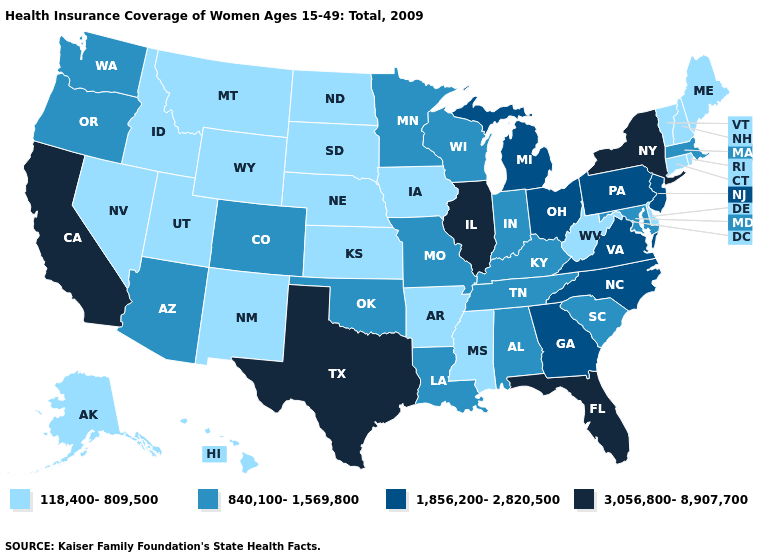Which states hav the highest value in the MidWest?
Short answer required. Illinois. Name the states that have a value in the range 118,400-809,500?
Write a very short answer. Alaska, Arkansas, Connecticut, Delaware, Hawaii, Idaho, Iowa, Kansas, Maine, Mississippi, Montana, Nebraska, Nevada, New Hampshire, New Mexico, North Dakota, Rhode Island, South Dakota, Utah, Vermont, West Virginia, Wyoming. Name the states that have a value in the range 3,056,800-8,907,700?
Quick response, please. California, Florida, Illinois, New York, Texas. What is the lowest value in the USA?
Write a very short answer. 118,400-809,500. Name the states that have a value in the range 118,400-809,500?
Concise answer only. Alaska, Arkansas, Connecticut, Delaware, Hawaii, Idaho, Iowa, Kansas, Maine, Mississippi, Montana, Nebraska, Nevada, New Hampshire, New Mexico, North Dakota, Rhode Island, South Dakota, Utah, Vermont, West Virginia, Wyoming. Name the states that have a value in the range 840,100-1,569,800?
Keep it brief. Alabama, Arizona, Colorado, Indiana, Kentucky, Louisiana, Maryland, Massachusetts, Minnesota, Missouri, Oklahoma, Oregon, South Carolina, Tennessee, Washington, Wisconsin. Does Rhode Island have the lowest value in the Northeast?
Be succinct. Yes. Among the states that border New York , which have the highest value?
Short answer required. New Jersey, Pennsylvania. Among the states that border West Virginia , which have the lowest value?
Quick response, please. Kentucky, Maryland. Name the states that have a value in the range 3,056,800-8,907,700?
Concise answer only. California, Florida, Illinois, New York, Texas. Is the legend a continuous bar?
Concise answer only. No. What is the highest value in states that border Iowa?
Concise answer only. 3,056,800-8,907,700. Name the states that have a value in the range 1,856,200-2,820,500?
Keep it brief. Georgia, Michigan, New Jersey, North Carolina, Ohio, Pennsylvania, Virginia. Name the states that have a value in the range 840,100-1,569,800?
Answer briefly. Alabama, Arizona, Colorado, Indiana, Kentucky, Louisiana, Maryland, Massachusetts, Minnesota, Missouri, Oklahoma, Oregon, South Carolina, Tennessee, Washington, Wisconsin. Name the states that have a value in the range 118,400-809,500?
Answer briefly. Alaska, Arkansas, Connecticut, Delaware, Hawaii, Idaho, Iowa, Kansas, Maine, Mississippi, Montana, Nebraska, Nevada, New Hampshire, New Mexico, North Dakota, Rhode Island, South Dakota, Utah, Vermont, West Virginia, Wyoming. 